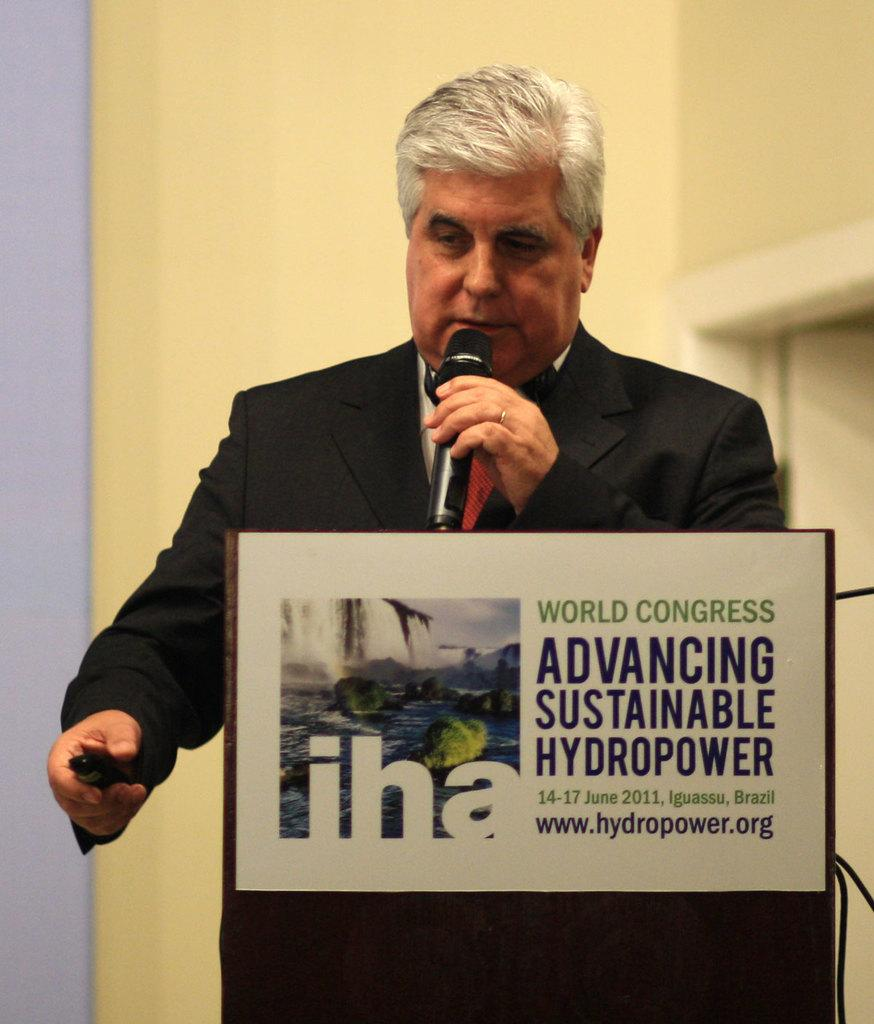Who is the person in the image? There is a man in the image. What is the man wearing? The man is wearing a black dress. What is the man holding in his hand? The man is holding a microphone and a remote. What is the man standing in front of? The man is standing in front of a podium. What can be seen on the podium? There is text written on the podium. What type of cattle can be seen grazing in the background of the image? There is no cattle present in the image; it features a man standing in front of a podium. 